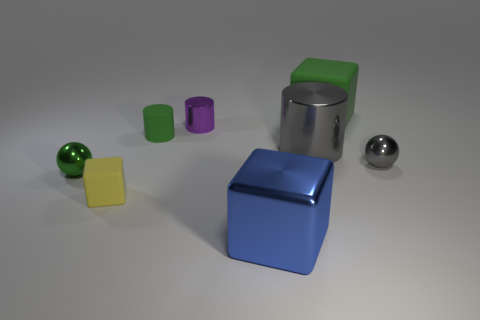Subtract all tiny cylinders. How many cylinders are left? 1 Add 1 blue metal spheres. How many objects exist? 9 Subtract all green balls. How many balls are left? 1 Subtract 1 spheres. How many spheres are left? 1 Subtract all cylinders. How many objects are left? 5 Subtract all yellow cylinders. How many green cubes are left? 1 Subtract all rubber objects. Subtract all red metal cylinders. How many objects are left? 5 Add 3 tiny green metal balls. How many tiny green metal balls are left? 4 Add 3 metal cubes. How many metal cubes exist? 4 Subtract 0 blue spheres. How many objects are left? 8 